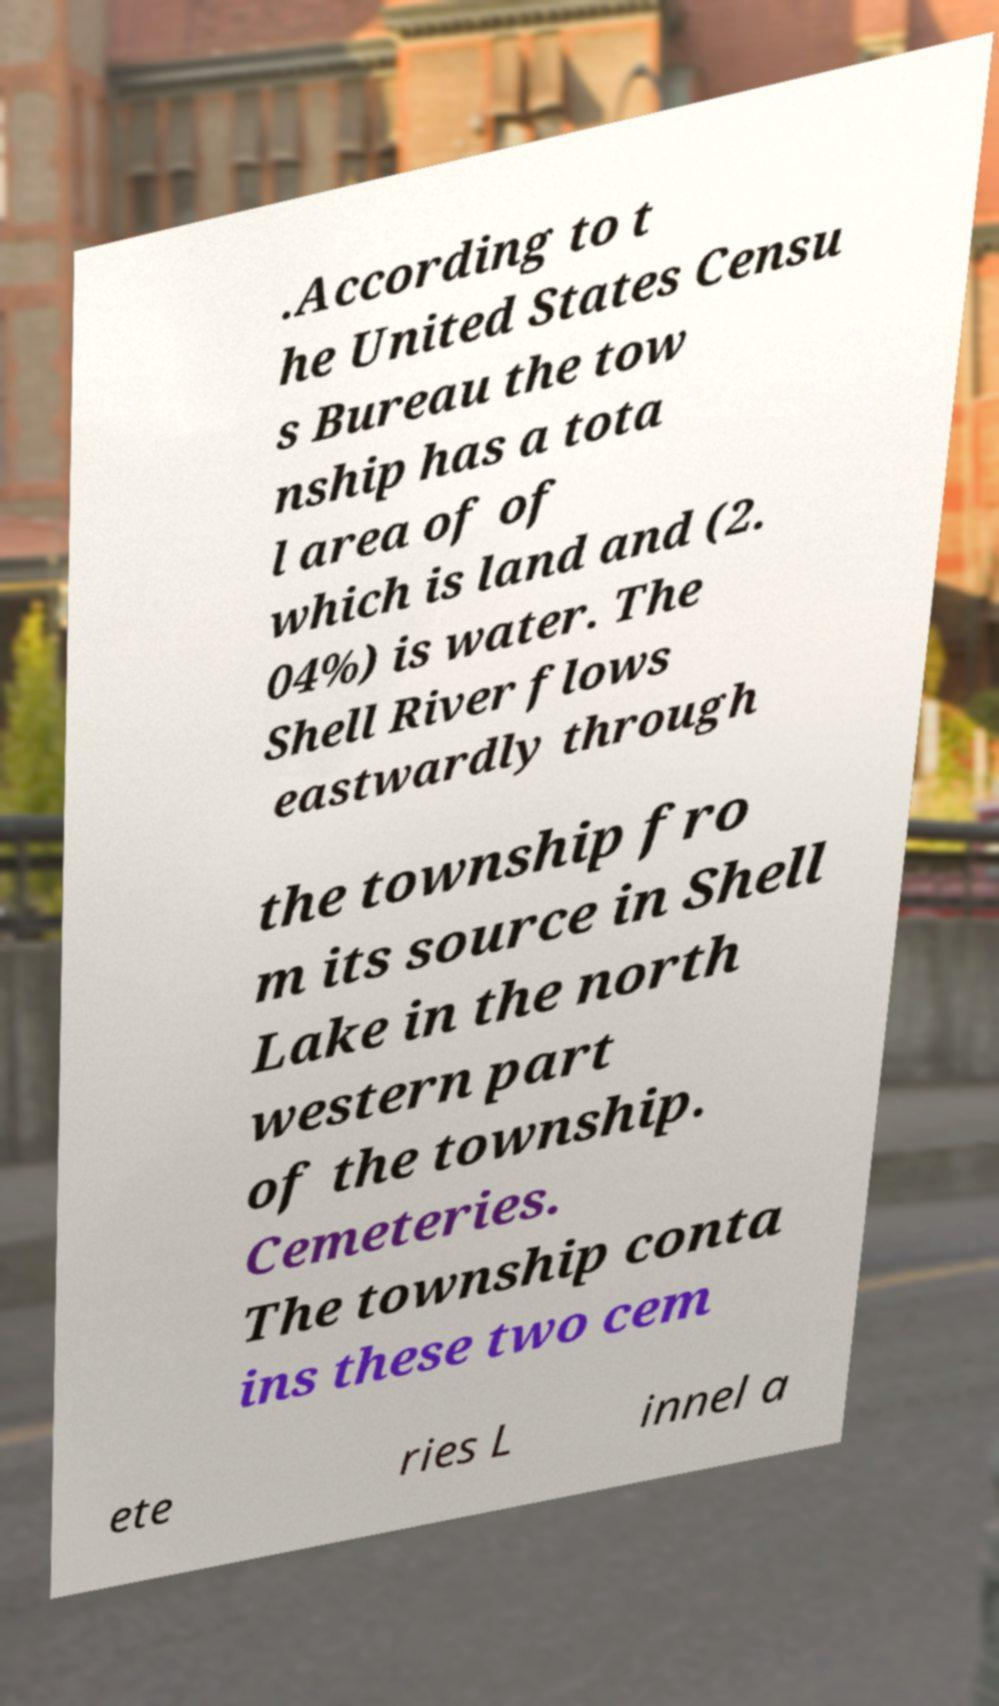I need the written content from this picture converted into text. Can you do that? .According to t he United States Censu s Bureau the tow nship has a tota l area of of which is land and (2. 04%) is water. The Shell River flows eastwardly through the township fro m its source in Shell Lake in the north western part of the township. Cemeteries. The township conta ins these two cem ete ries L innel a 